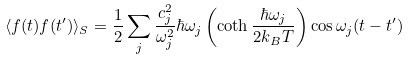<formula> <loc_0><loc_0><loc_500><loc_500>\langle f ( t ) f ( t ^ { \prime } ) \rangle _ { S } = \frac { 1 } { 2 } \sum _ { j } \frac { c _ { j } ^ { 2 } } { \omega _ { j } ^ { 2 } } \hbar { \omega } _ { j } \left ( \coth \frac { \hbar { \omega } _ { j } } { 2 k _ { B } T } \right ) \cos \omega _ { j } ( t - t ^ { \prime } )</formula> 